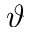Convert formula to latex. <formula><loc_0><loc_0><loc_500><loc_500>\vartheta</formula> 